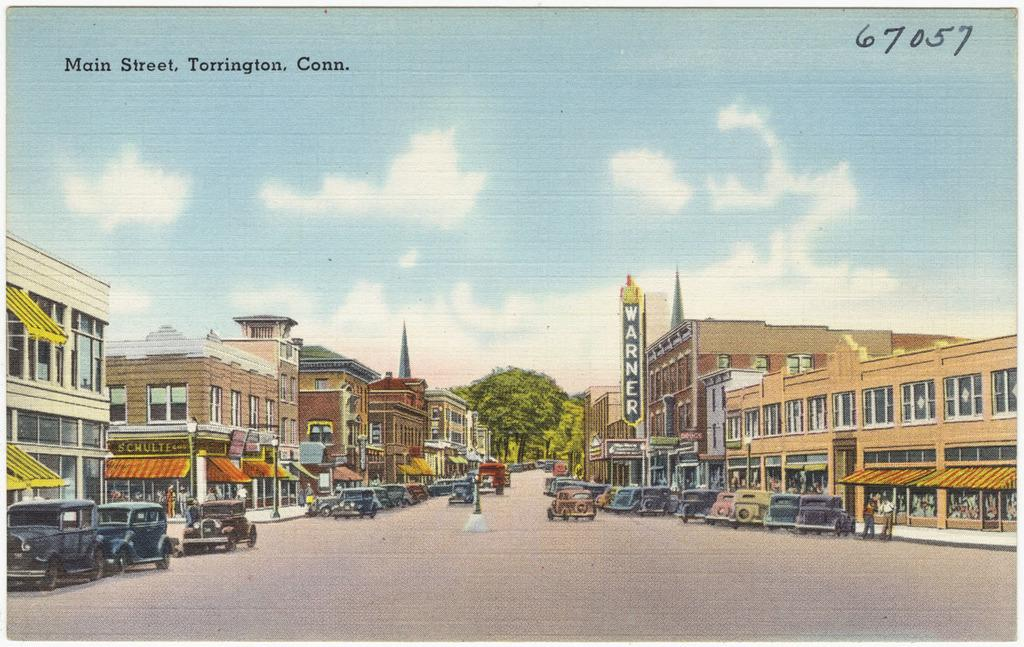What is the main subject of the painting in the image? The painting contains a depiction of buildings. What other elements are included in the painting? The painting includes vehicles and trees. What can be seen in the background of the painting? The sky is visible in the background of the image, along with other objects. Is there any text or writing on the image? Yes, there is writing on the image. How many bats are flying in the image? There are no bats present in the image. What type of motion is depicted in the image? The image is a painting, so there is no motion depicted; it is a static representation of the scene. 